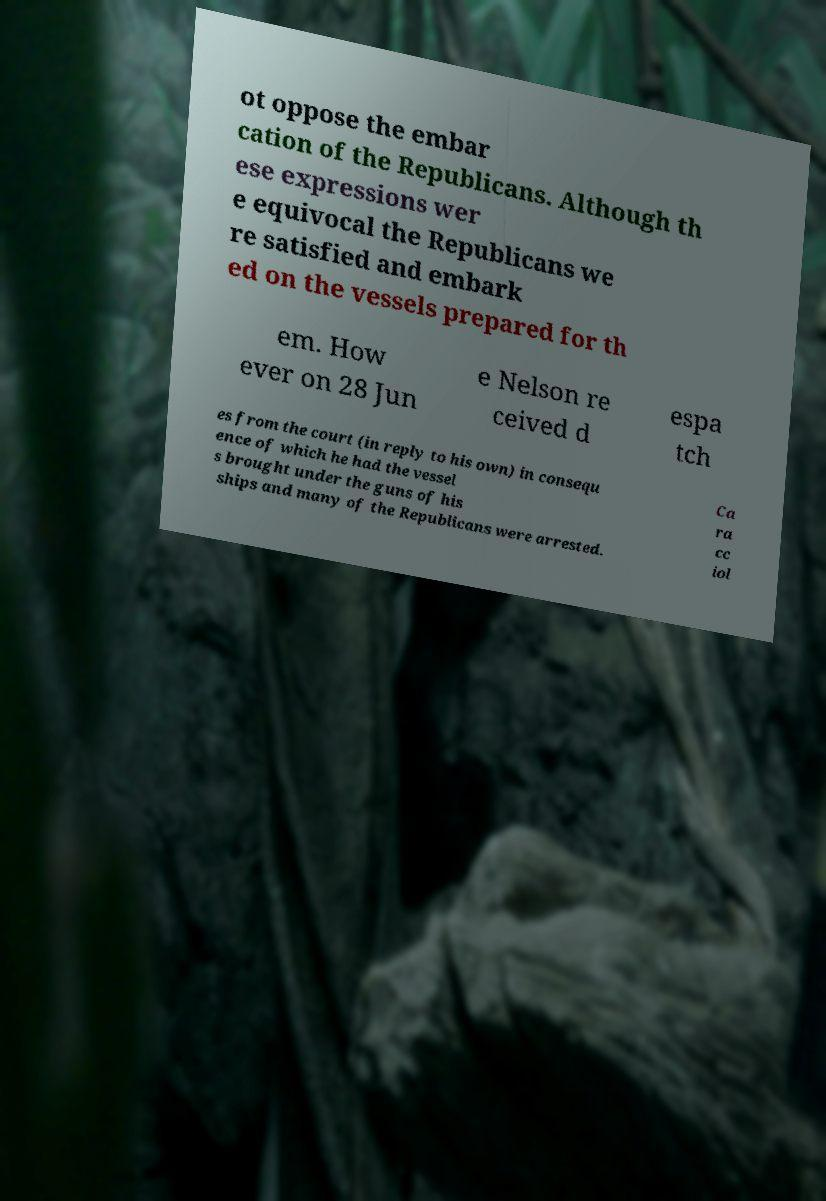Can you accurately transcribe the text from the provided image for me? ot oppose the embar cation of the Republicans. Although th ese expressions wer e equivocal the Republicans we re satisfied and embark ed on the vessels prepared for th em. How ever on 28 Jun e Nelson re ceived d espa tch es from the court (in reply to his own) in consequ ence of which he had the vessel s brought under the guns of his ships and many of the Republicans were arrested. Ca ra cc iol 